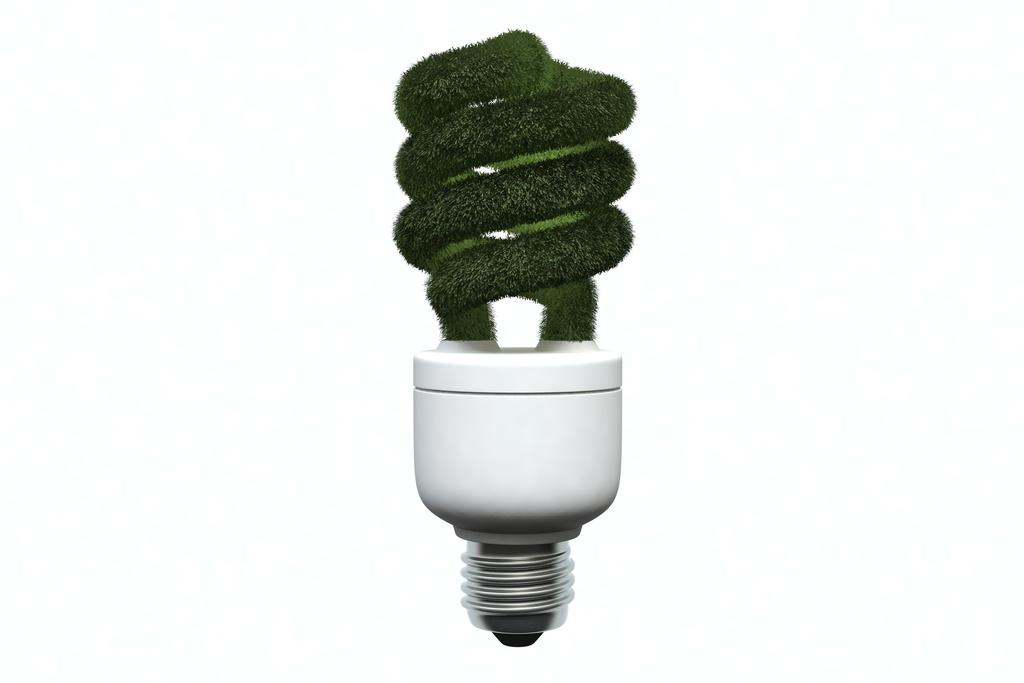What object is present in the image with a unique color feature? There is a light bulb in the image with a green color spiral. Can you describe the color of the light bulb? The light bulb has a green color spiral. What type of glue is being used to attach the moon to the night sky in the image? There is no moon or night sky present in the image, and therefore no glue or attachment process can be observed. 